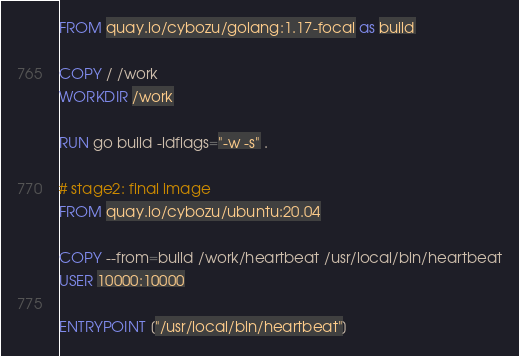Convert code to text. <code><loc_0><loc_0><loc_500><loc_500><_Dockerfile_>FROM quay.io/cybozu/golang:1.17-focal as build

COPY / /work
WORKDIR /work

RUN go build -ldflags="-w -s" .

# stage2: final image
FROM quay.io/cybozu/ubuntu:20.04

COPY --from=build /work/heartbeat /usr/local/bin/heartbeat
USER 10000:10000

ENTRYPOINT ["/usr/local/bin/heartbeat"]
</code> 